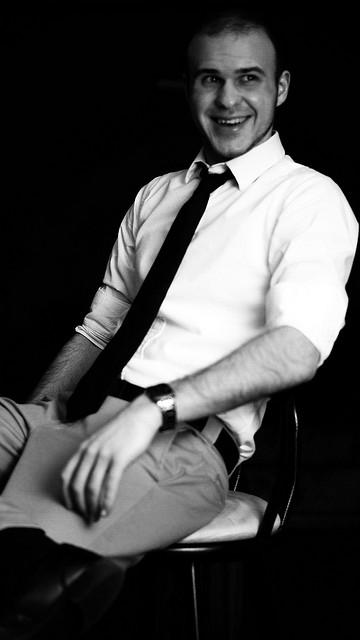What is this person wearing on  his left hand?
Concise answer only. Watch. Does this person look sad?
Short answer required. No. Is he sitting down?
Short answer required. Yes. 